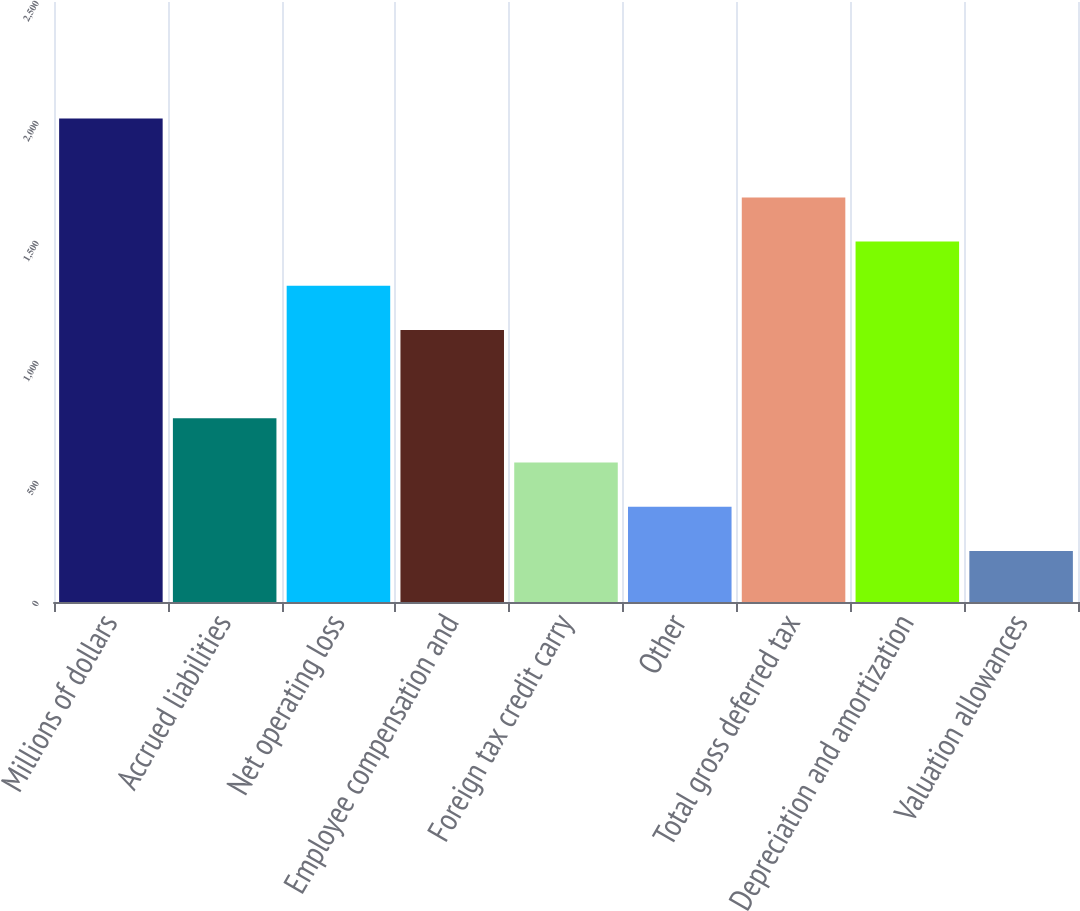<chart> <loc_0><loc_0><loc_500><loc_500><bar_chart><fcel>Millions of dollars<fcel>Accrued liabilities<fcel>Net operating loss<fcel>Employee compensation and<fcel>Foreign tax credit carry<fcel>Other<fcel>Total gross deferred tax<fcel>Depreciation and amortization<fcel>Valuation allowances<nl><fcel>2015<fcel>765.3<fcel>1317.6<fcel>1133.5<fcel>581.2<fcel>397.1<fcel>1685.8<fcel>1501.7<fcel>213<nl></chart> 